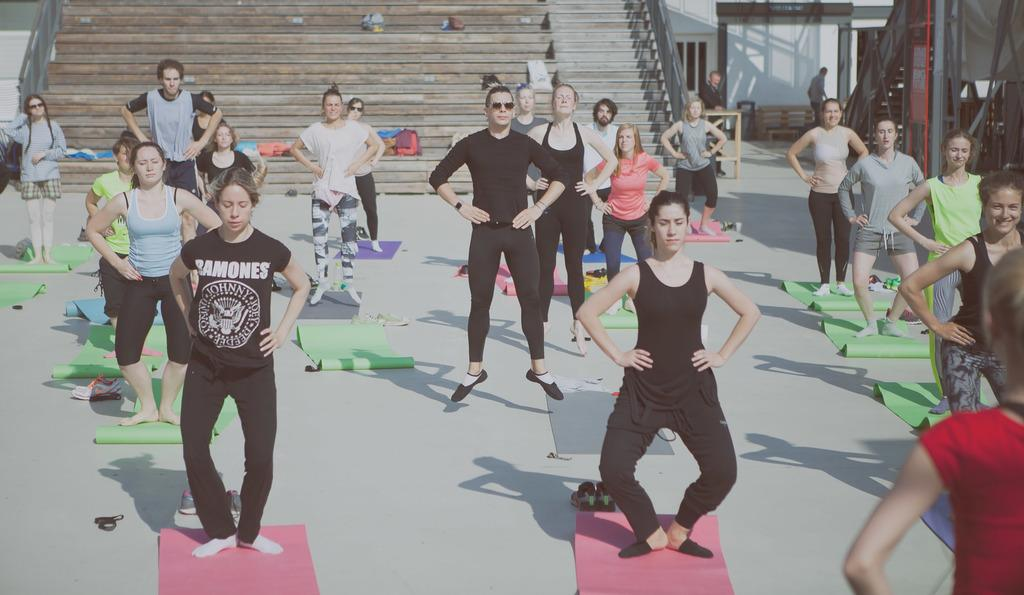What are the people in the image doing? The people in the image are doing exercise. What architectural feature can be seen in the image? There are stairs visible in the image. What is the background of the image composed of? There is a wall in the image. What type of rhythm is the stranger playing on the farmer's guitar in the image? There is no stranger or farmer present in the image, nor is there a guitar or any music being played. 